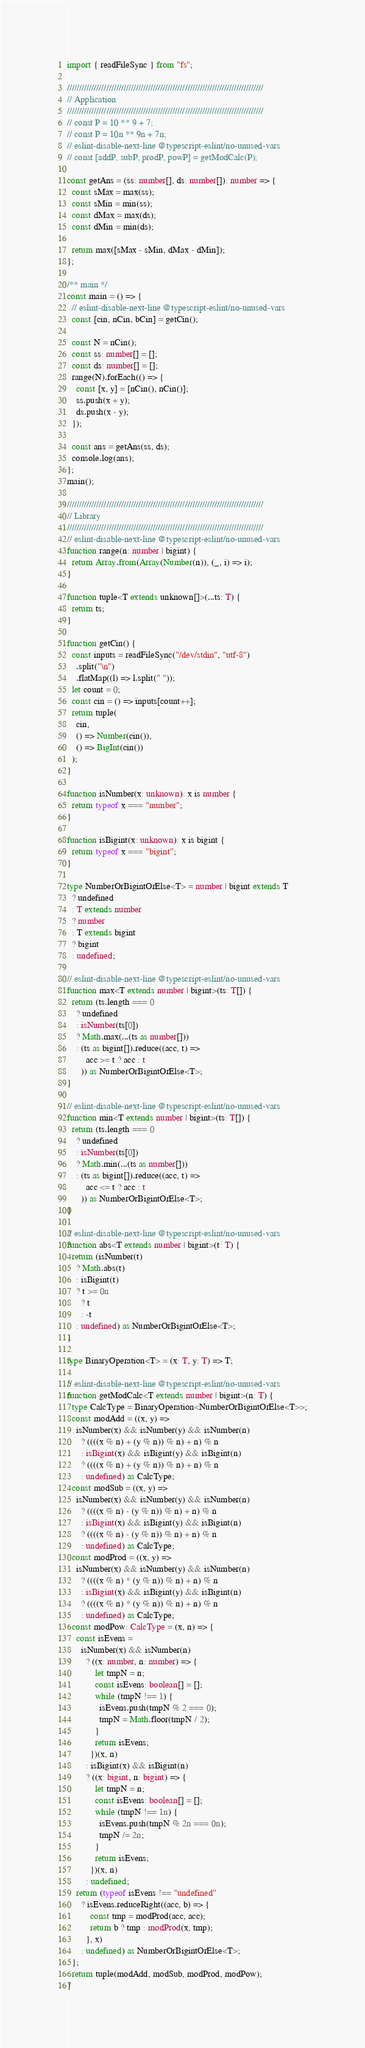Convert code to text. <code><loc_0><loc_0><loc_500><loc_500><_TypeScript_>import { readFileSync } from "fs";

////////////////////////////////////////////////////////////////////////////////
// Application
////////////////////////////////////////////////////////////////////////////////
// const P = 10 ** 9 + 7;
// const P = 10n ** 9n + 7n;
// eslint-disable-next-line @typescript-eslint/no-unused-vars
// const [addP, subP, prodP, powP] = getModCalc(P);

const getAns = (ss: number[], ds: number[]): number => {
  const sMax = max(ss);
  const sMin = min(ss);
  const dMax = max(ds);
  const dMin = min(ds);

  return max([sMax - sMin, dMax - dMin]);
};

/** main */
const main = () => {
  // eslint-disable-next-line @typescript-eslint/no-unused-vars
  const [cin, nCin, bCin] = getCin();

  const N = nCin();
  const ss: number[] = [];
  const ds: number[] = [];
  range(N).forEach(() => {
    const [x, y] = [nCin(), nCin()];
    ss.push(x + y);
    ds.push(x - y);
  });

  const ans = getAns(ss, ds);
  console.log(ans);
};
main();

////////////////////////////////////////////////////////////////////////////////
// Library
////////////////////////////////////////////////////////////////////////////////
// eslint-disable-next-line @typescript-eslint/no-unused-vars
function range(n: number | bigint) {
  return Array.from(Array(Number(n)), (_, i) => i);
}

function tuple<T extends unknown[]>(...ts: T) {
  return ts;
}

function getCin() {
  const inputs = readFileSync("/dev/stdin", "utf-8")
    .split("\n")
    .flatMap((l) => l.split(" "));
  let count = 0;
  const cin = () => inputs[count++];
  return tuple(
    cin,
    () => Number(cin()),
    () => BigInt(cin())
  );
}

function isNumber(x: unknown): x is number {
  return typeof x === "number";
}

function isBigint(x: unknown): x is bigint {
  return typeof x === "bigint";
}

type NumberOrBigintOrElse<T> = number | bigint extends T
  ? undefined
  : T extends number
  ? number
  : T extends bigint
  ? bigint
  : undefined;

// eslint-disable-next-line @typescript-eslint/no-unused-vars
function max<T extends number | bigint>(ts: T[]) {
  return (ts.length === 0
    ? undefined
    : isNumber(ts[0])
    ? Math.max(...(ts as number[]))
    : (ts as bigint[]).reduce((acc, t) =>
        acc >= t ? acc : t
      )) as NumberOrBigintOrElse<T>;
}

// eslint-disable-next-line @typescript-eslint/no-unused-vars
function min<T extends number | bigint>(ts: T[]) {
  return (ts.length === 0
    ? undefined
    : isNumber(ts[0])
    ? Math.min(...(ts as number[]))
    : (ts as bigint[]).reduce((acc, t) =>
        acc <= t ? acc : t
      )) as NumberOrBigintOrElse<T>;
}

// eslint-disable-next-line @typescript-eslint/no-unused-vars
function abs<T extends number | bigint>(t: T) {
  return (isNumber(t)
    ? Math.abs(t)
    : isBigint(t)
    ? t >= 0n
      ? t
      : -t
    : undefined) as NumberOrBigintOrElse<T>;
}

type BinaryOperation<T> = (x: T, y: T) => T;

// eslint-disable-next-line @typescript-eslint/no-unused-vars
function getModCalc<T extends number | bigint>(n: T) {
  type CalcType = BinaryOperation<NumberOrBigintOrElse<T>>;
  const modAdd = ((x, y) =>
    isNumber(x) && isNumber(y) && isNumber(n)
      ? ((((x % n) + (y % n)) % n) + n) % n
      : isBigint(x) && isBigint(y) && isBigint(n)
      ? ((((x % n) + (y % n)) % n) + n) % n
      : undefined) as CalcType;
  const modSub = ((x, y) =>
    isNumber(x) && isNumber(y) && isNumber(n)
      ? ((((x % n) - (y % n)) % n) + n) % n
      : isBigint(x) && isBigint(y) && isBigint(n)
      ? ((((x % n) - (y % n)) % n) + n) % n
      : undefined) as CalcType;
  const modProd = ((x, y) =>
    isNumber(x) && isNumber(y) && isNumber(n)
      ? ((((x % n) * (y % n)) % n) + n) % n
      : isBigint(x) && isBigint(y) && isBigint(n)
      ? ((((x % n) * (y % n)) % n) + n) % n
      : undefined) as CalcType;
  const modPow: CalcType = (x, n) => {
    const isEvens =
      isNumber(x) && isNumber(n)
        ? ((x: number, n: number) => {
            let tmpN = n;
            const isEvens: boolean[] = [];
            while (tmpN !== 1) {
              isEvens.push(tmpN % 2 === 0);
              tmpN = Math.floor(tmpN / 2);
            }
            return isEvens;
          })(x, n)
        : isBigint(x) && isBigint(n)
        ? ((x: bigint, n: bigint) => {
            let tmpN = n;
            const isEvens: boolean[] = [];
            while (tmpN !== 1n) {
              isEvens.push(tmpN % 2n === 0n);
              tmpN /= 2n;
            }
            return isEvens;
          })(x, n)
        : undefined;
    return (typeof isEvens !== "undefined"
      ? isEvens.reduceRight((acc, b) => {
          const tmp = modProd(acc, acc);
          return b ? tmp : modProd(x, tmp);
        }, x)
      : undefined) as NumberOrBigintOrElse<T>;
  };
  return tuple(modAdd, modSub, modProd, modPow);
}
</code> 